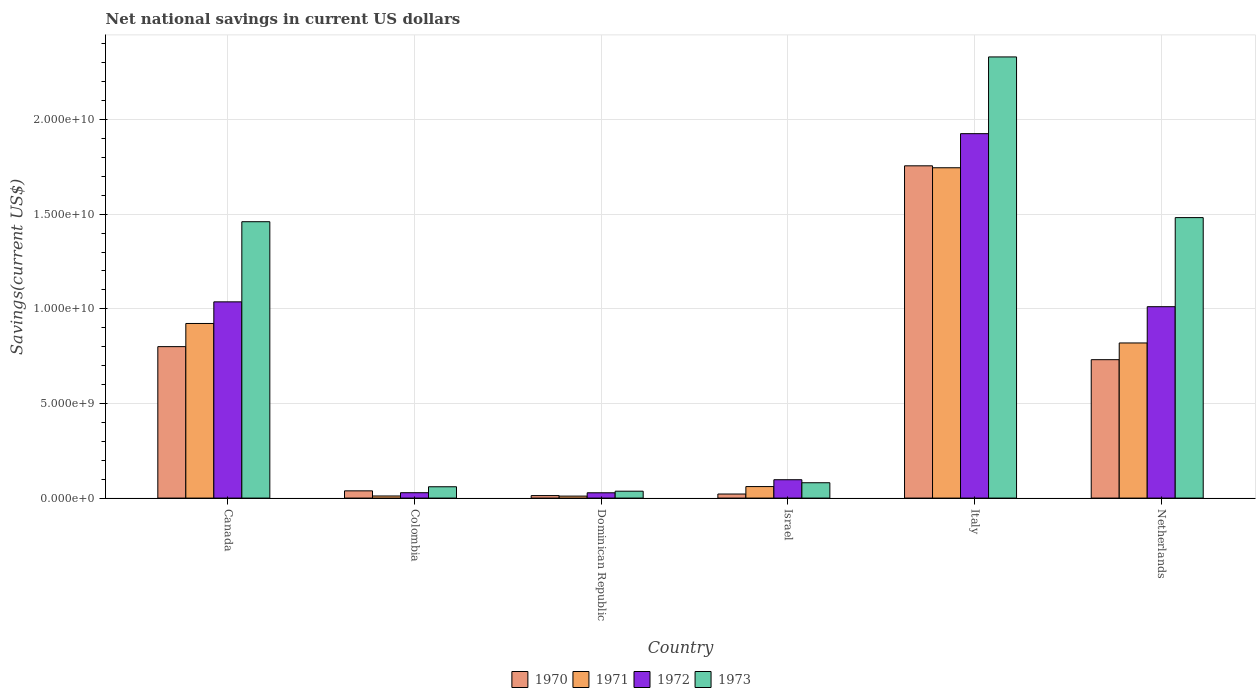How many groups of bars are there?
Give a very brief answer. 6. Are the number of bars on each tick of the X-axis equal?
Offer a very short reply. Yes. How many bars are there on the 2nd tick from the left?
Keep it short and to the point. 4. What is the label of the 1st group of bars from the left?
Make the answer very short. Canada. What is the net national savings in 1971 in Dominican Republic?
Your answer should be very brief. 1.05e+08. Across all countries, what is the maximum net national savings in 1971?
Offer a terse response. 1.75e+1. Across all countries, what is the minimum net national savings in 1970?
Provide a succinct answer. 1.33e+08. In which country was the net national savings in 1972 minimum?
Offer a terse response. Dominican Republic. What is the total net national savings in 1970 in the graph?
Ensure brevity in your answer.  3.36e+1. What is the difference between the net national savings in 1970 in Canada and that in Israel?
Your answer should be very brief. 7.79e+09. What is the difference between the net national savings in 1972 in Canada and the net national savings in 1973 in Colombia?
Ensure brevity in your answer.  9.77e+09. What is the average net national savings in 1970 per country?
Your answer should be compact. 5.60e+09. What is the difference between the net national savings of/in 1972 and net national savings of/in 1970 in Netherlands?
Provide a short and direct response. 2.80e+09. In how many countries, is the net national savings in 1972 greater than 4000000000 US$?
Provide a short and direct response. 3. What is the ratio of the net national savings in 1970 in Canada to that in Israel?
Ensure brevity in your answer.  37.28. Is the net national savings in 1970 in Canada less than that in Netherlands?
Offer a very short reply. No. What is the difference between the highest and the second highest net national savings in 1971?
Provide a short and direct response. 9.26e+09. What is the difference between the highest and the lowest net national savings in 1972?
Make the answer very short. 1.90e+1. In how many countries, is the net national savings in 1973 greater than the average net national savings in 1973 taken over all countries?
Your answer should be very brief. 3. Is the sum of the net national savings in 1973 in Dominican Republic and Netherlands greater than the maximum net national savings in 1972 across all countries?
Your answer should be very brief. No. Is it the case that in every country, the sum of the net national savings in 1970 and net national savings in 1973 is greater than the sum of net national savings in 1972 and net national savings in 1971?
Offer a terse response. No. What does the 1st bar from the left in Netherlands represents?
Offer a very short reply. 1970. What does the 4th bar from the right in Italy represents?
Your response must be concise. 1970. Is it the case that in every country, the sum of the net national savings in 1973 and net national savings in 1971 is greater than the net national savings in 1972?
Offer a very short reply. Yes. Are all the bars in the graph horizontal?
Your answer should be very brief. No. How many countries are there in the graph?
Provide a short and direct response. 6. What is the difference between two consecutive major ticks on the Y-axis?
Provide a short and direct response. 5.00e+09. Does the graph contain grids?
Keep it short and to the point. Yes. Where does the legend appear in the graph?
Offer a terse response. Bottom center. How many legend labels are there?
Offer a very short reply. 4. How are the legend labels stacked?
Provide a succinct answer. Horizontal. What is the title of the graph?
Your response must be concise. Net national savings in current US dollars. Does "2006" appear as one of the legend labels in the graph?
Offer a terse response. No. What is the label or title of the Y-axis?
Your response must be concise. Savings(current US$). What is the Savings(current US$) of 1970 in Canada?
Give a very brief answer. 8.00e+09. What is the Savings(current US$) in 1971 in Canada?
Keep it short and to the point. 9.23e+09. What is the Savings(current US$) in 1972 in Canada?
Keep it short and to the point. 1.04e+1. What is the Savings(current US$) in 1973 in Canada?
Keep it short and to the point. 1.46e+1. What is the Savings(current US$) in 1970 in Colombia?
Ensure brevity in your answer.  3.83e+08. What is the Savings(current US$) of 1971 in Colombia?
Your response must be concise. 1.11e+08. What is the Savings(current US$) in 1972 in Colombia?
Your answer should be compact. 2.84e+08. What is the Savings(current US$) in 1973 in Colombia?
Make the answer very short. 5.98e+08. What is the Savings(current US$) in 1970 in Dominican Republic?
Your response must be concise. 1.33e+08. What is the Savings(current US$) in 1971 in Dominican Republic?
Provide a succinct answer. 1.05e+08. What is the Savings(current US$) of 1972 in Dominican Republic?
Your answer should be very brief. 2.80e+08. What is the Savings(current US$) of 1973 in Dominican Republic?
Offer a terse response. 3.65e+08. What is the Savings(current US$) of 1970 in Israel?
Offer a very short reply. 2.15e+08. What is the Savings(current US$) of 1971 in Israel?
Ensure brevity in your answer.  6.09e+08. What is the Savings(current US$) in 1972 in Israel?
Offer a very short reply. 9.71e+08. What is the Savings(current US$) in 1973 in Israel?
Your answer should be compact. 8.11e+08. What is the Savings(current US$) in 1970 in Italy?
Make the answer very short. 1.76e+1. What is the Savings(current US$) of 1971 in Italy?
Give a very brief answer. 1.75e+1. What is the Savings(current US$) of 1972 in Italy?
Your answer should be very brief. 1.93e+1. What is the Savings(current US$) in 1973 in Italy?
Keep it short and to the point. 2.33e+1. What is the Savings(current US$) in 1970 in Netherlands?
Your answer should be compact. 7.31e+09. What is the Savings(current US$) of 1971 in Netherlands?
Keep it short and to the point. 8.20e+09. What is the Savings(current US$) in 1972 in Netherlands?
Offer a very short reply. 1.01e+1. What is the Savings(current US$) of 1973 in Netherlands?
Make the answer very short. 1.48e+1. Across all countries, what is the maximum Savings(current US$) of 1970?
Offer a very short reply. 1.76e+1. Across all countries, what is the maximum Savings(current US$) in 1971?
Your answer should be compact. 1.75e+1. Across all countries, what is the maximum Savings(current US$) in 1972?
Ensure brevity in your answer.  1.93e+1. Across all countries, what is the maximum Savings(current US$) in 1973?
Your response must be concise. 2.33e+1. Across all countries, what is the minimum Savings(current US$) of 1970?
Keep it short and to the point. 1.33e+08. Across all countries, what is the minimum Savings(current US$) of 1971?
Offer a terse response. 1.05e+08. Across all countries, what is the minimum Savings(current US$) in 1972?
Give a very brief answer. 2.80e+08. Across all countries, what is the minimum Savings(current US$) of 1973?
Give a very brief answer. 3.65e+08. What is the total Savings(current US$) of 1970 in the graph?
Make the answer very short. 3.36e+1. What is the total Savings(current US$) of 1971 in the graph?
Provide a short and direct response. 3.57e+1. What is the total Savings(current US$) in 1972 in the graph?
Provide a succinct answer. 4.13e+1. What is the total Savings(current US$) in 1973 in the graph?
Your answer should be compact. 5.45e+1. What is the difference between the Savings(current US$) of 1970 in Canada and that in Colombia?
Offer a very short reply. 7.62e+09. What is the difference between the Savings(current US$) in 1971 in Canada and that in Colombia?
Make the answer very short. 9.11e+09. What is the difference between the Savings(current US$) in 1972 in Canada and that in Colombia?
Give a very brief answer. 1.01e+1. What is the difference between the Savings(current US$) of 1973 in Canada and that in Colombia?
Offer a terse response. 1.40e+1. What is the difference between the Savings(current US$) of 1970 in Canada and that in Dominican Republic?
Offer a terse response. 7.87e+09. What is the difference between the Savings(current US$) of 1971 in Canada and that in Dominican Republic?
Provide a succinct answer. 9.12e+09. What is the difference between the Savings(current US$) of 1972 in Canada and that in Dominican Republic?
Offer a very short reply. 1.01e+1. What is the difference between the Savings(current US$) in 1973 in Canada and that in Dominican Republic?
Offer a terse response. 1.42e+1. What is the difference between the Savings(current US$) in 1970 in Canada and that in Israel?
Provide a short and direct response. 7.79e+09. What is the difference between the Savings(current US$) of 1971 in Canada and that in Israel?
Ensure brevity in your answer.  8.62e+09. What is the difference between the Savings(current US$) of 1972 in Canada and that in Israel?
Keep it short and to the point. 9.40e+09. What is the difference between the Savings(current US$) of 1973 in Canada and that in Israel?
Your answer should be compact. 1.38e+1. What is the difference between the Savings(current US$) in 1970 in Canada and that in Italy?
Offer a very short reply. -9.55e+09. What is the difference between the Savings(current US$) of 1971 in Canada and that in Italy?
Give a very brief answer. -8.23e+09. What is the difference between the Savings(current US$) of 1972 in Canada and that in Italy?
Offer a terse response. -8.89e+09. What is the difference between the Savings(current US$) of 1973 in Canada and that in Italy?
Make the answer very short. -8.71e+09. What is the difference between the Savings(current US$) of 1970 in Canada and that in Netherlands?
Offer a terse response. 6.89e+08. What is the difference between the Savings(current US$) of 1971 in Canada and that in Netherlands?
Your response must be concise. 1.03e+09. What is the difference between the Savings(current US$) in 1972 in Canada and that in Netherlands?
Offer a very short reply. 2.56e+08. What is the difference between the Savings(current US$) in 1973 in Canada and that in Netherlands?
Provide a succinct answer. -2.17e+08. What is the difference between the Savings(current US$) of 1970 in Colombia and that in Dominican Republic?
Provide a short and direct response. 2.50e+08. What is the difference between the Savings(current US$) of 1971 in Colombia and that in Dominican Republic?
Your answer should be compact. 6.03e+06. What is the difference between the Savings(current US$) in 1972 in Colombia and that in Dominican Republic?
Offer a very short reply. 3.48e+06. What is the difference between the Savings(current US$) in 1973 in Colombia and that in Dominican Republic?
Keep it short and to the point. 2.34e+08. What is the difference between the Savings(current US$) of 1970 in Colombia and that in Israel?
Give a very brief answer. 1.68e+08. What is the difference between the Savings(current US$) in 1971 in Colombia and that in Israel?
Offer a very short reply. -4.97e+08. What is the difference between the Savings(current US$) in 1972 in Colombia and that in Israel?
Offer a terse response. -6.87e+08. What is the difference between the Savings(current US$) of 1973 in Colombia and that in Israel?
Provide a short and direct response. -2.12e+08. What is the difference between the Savings(current US$) in 1970 in Colombia and that in Italy?
Your response must be concise. -1.72e+1. What is the difference between the Savings(current US$) of 1971 in Colombia and that in Italy?
Keep it short and to the point. -1.73e+1. What is the difference between the Savings(current US$) of 1972 in Colombia and that in Italy?
Provide a short and direct response. -1.90e+1. What is the difference between the Savings(current US$) in 1973 in Colombia and that in Italy?
Provide a short and direct response. -2.27e+1. What is the difference between the Savings(current US$) in 1970 in Colombia and that in Netherlands?
Your answer should be very brief. -6.93e+09. What is the difference between the Savings(current US$) in 1971 in Colombia and that in Netherlands?
Offer a terse response. -8.08e+09. What is the difference between the Savings(current US$) of 1972 in Colombia and that in Netherlands?
Ensure brevity in your answer.  -9.83e+09. What is the difference between the Savings(current US$) of 1973 in Colombia and that in Netherlands?
Offer a very short reply. -1.42e+1. What is the difference between the Savings(current US$) in 1970 in Dominican Republic and that in Israel?
Make the answer very short. -8.19e+07. What is the difference between the Savings(current US$) in 1971 in Dominican Republic and that in Israel?
Your answer should be compact. -5.03e+08. What is the difference between the Savings(current US$) of 1972 in Dominican Republic and that in Israel?
Give a very brief answer. -6.90e+08. What is the difference between the Savings(current US$) in 1973 in Dominican Republic and that in Israel?
Offer a very short reply. -4.46e+08. What is the difference between the Savings(current US$) of 1970 in Dominican Republic and that in Italy?
Give a very brief answer. -1.74e+1. What is the difference between the Savings(current US$) of 1971 in Dominican Republic and that in Italy?
Offer a very short reply. -1.73e+1. What is the difference between the Savings(current US$) in 1972 in Dominican Republic and that in Italy?
Provide a succinct answer. -1.90e+1. What is the difference between the Savings(current US$) of 1973 in Dominican Republic and that in Italy?
Your answer should be compact. -2.29e+1. What is the difference between the Savings(current US$) in 1970 in Dominican Republic and that in Netherlands?
Keep it short and to the point. -7.18e+09. What is the difference between the Savings(current US$) of 1971 in Dominican Republic and that in Netherlands?
Give a very brief answer. -8.09e+09. What is the difference between the Savings(current US$) of 1972 in Dominican Republic and that in Netherlands?
Provide a succinct answer. -9.83e+09. What is the difference between the Savings(current US$) in 1973 in Dominican Republic and that in Netherlands?
Your response must be concise. -1.45e+1. What is the difference between the Savings(current US$) of 1970 in Israel and that in Italy?
Offer a terse response. -1.73e+1. What is the difference between the Savings(current US$) of 1971 in Israel and that in Italy?
Your answer should be very brief. -1.68e+1. What is the difference between the Savings(current US$) of 1972 in Israel and that in Italy?
Your answer should be compact. -1.83e+1. What is the difference between the Savings(current US$) of 1973 in Israel and that in Italy?
Make the answer very short. -2.25e+1. What is the difference between the Savings(current US$) in 1970 in Israel and that in Netherlands?
Keep it short and to the point. -7.10e+09. What is the difference between the Savings(current US$) of 1971 in Israel and that in Netherlands?
Ensure brevity in your answer.  -7.59e+09. What is the difference between the Savings(current US$) of 1972 in Israel and that in Netherlands?
Give a very brief answer. -9.14e+09. What is the difference between the Savings(current US$) in 1973 in Israel and that in Netherlands?
Your response must be concise. -1.40e+1. What is the difference between the Savings(current US$) in 1970 in Italy and that in Netherlands?
Your response must be concise. 1.02e+1. What is the difference between the Savings(current US$) in 1971 in Italy and that in Netherlands?
Provide a short and direct response. 9.26e+09. What is the difference between the Savings(current US$) of 1972 in Italy and that in Netherlands?
Make the answer very short. 9.14e+09. What is the difference between the Savings(current US$) of 1973 in Italy and that in Netherlands?
Provide a short and direct response. 8.49e+09. What is the difference between the Savings(current US$) in 1970 in Canada and the Savings(current US$) in 1971 in Colombia?
Provide a short and direct response. 7.89e+09. What is the difference between the Savings(current US$) of 1970 in Canada and the Savings(current US$) of 1972 in Colombia?
Make the answer very short. 7.72e+09. What is the difference between the Savings(current US$) in 1970 in Canada and the Savings(current US$) in 1973 in Colombia?
Your response must be concise. 7.40e+09. What is the difference between the Savings(current US$) of 1971 in Canada and the Savings(current US$) of 1972 in Colombia?
Keep it short and to the point. 8.94e+09. What is the difference between the Savings(current US$) of 1971 in Canada and the Savings(current US$) of 1973 in Colombia?
Give a very brief answer. 8.63e+09. What is the difference between the Savings(current US$) of 1972 in Canada and the Savings(current US$) of 1973 in Colombia?
Offer a very short reply. 9.77e+09. What is the difference between the Savings(current US$) in 1970 in Canada and the Savings(current US$) in 1971 in Dominican Republic?
Give a very brief answer. 7.90e+09. What is the difference between the Savings(current US$) in 1970 in Canada and the Savings(current US$) in 1972 in Dominican Republic?
Provide a short and direct response. 7.72e+09. What is the difference between the Savings(current US$) of 1970 in Canada and the Savings(current US$) of 1973 in Dominican Republic?
Your answer should be compact. 7.64e+09. What is the difference between the Savings(current US$) in 1971 in Canada and the Savings(current US$) in 1972 in Dominican Republic?
Give a very brief answer. 8.94e+09. What is the difference between the Savings(current US$) of 1971 in Canada and the Savings(current US$) of 1973 in Dominican Republic?
Give a very brief answer. 8.86e+09. What is the difference between the Savings(current US$) in 1972 in Canada and the Savings(current US$) in 1973 in Dominican Republic?
Provide a succinct answer. 1.00e+1. What is the difference between the Savings(current US$) in 1970 in Canada and the Savings(current US$) in 1971 in Israel?
Your answer should be compact. 7.39e+09. What is the difference between the Savings(current US$) in 1970 in Canada and the Savings(current US$) in 1972 in Israel?
Your answer should be very brief. 7.03e+09. What is the difference between the Savings(current US$) in 1970 in Canada and the Savings(current US$) in 1973 in Israel?
Keep it short and to the point. 7.19e+09. What is the difference between the Savings(current US$) in 1971 in Canada and the Savings(current US$) in 1972 in Israel?
Offer a terse response. 8.25e+09. What is the difference between the Savings(current US$) in 1971 in Canada and the Savings(current US$) in 1973 in Israel?
Give a very brief answer. 8.41e+09. What is the difference between the Savings(current US$) in 1972 in Canada and the Savings(current US$) in 1973 in Israel?
Ensure brevity in your answer.  9.56e+09. What is the difference between the Savings(current US$) in 1970 in Canada and the Savings(current US$) in 1971 in Italy?
Make the answer very short. -9.45e+09. What is the difference between the Savings(current US$) in 1970 in Canada and the Savings(current US$) in 1972 in Italy?
Your response must be concise. -1.13e+1. What is the difference between the Savings(current US$) in 1970 in Canada and the Savings(current US$) in 1973 in Italy?
Offer a terse response. -1.53e+1. What is the difference between the Savings(current US$) of 1971 in Canada and the Savings(current US$) of 1972 in Italy?
Keep it short and to the point. -1.00e+1. What is the difference between the Savings(current US$) in 1971 in Canada and the Savings(current US$) in 1973 in Italy?
Offer a very short reply. -1.41e+1. What is the difference between the Savings(current US$) in 1972 in Canada and the Savings(current US$) in 1973 in Italy?
Your answer should be very brief. -1.29e+1. What is the difference between the Savings(current US$) of 1970 in Canada and the Savings(current US$) of 1971 in Netherlands?
Ensure brevity in your answer.  -1.94e+08. What is the difference between the Savings(current US$) of 1970 in Canada and the Savings(current US$) of 1972 in Netherlands?
Offer a terse response. -2.11e+09. What is the difference between the Savings(current US$) of 1970 in Canada and the Savings(current US$) of 1973 in Netherlands?
Ensure brevity in your answer.  -6.82e+09. What is the difference between the Savings(current US$) of 1971 in Canada and the Savings(current US$) of 1972 in Netherlands?
Provide a succinct answer. -8.87e+08. What is the difference between the Savings(current US$) of 1971 in Canada and the Savings(current US$) of 1973 in Netherlands?
Offer a very short reply. -5.59e+09. What is the difference between the Savings(current US$) in 1972 in Canada and the Savings(current US$) in 1973 in Netherlands?
Your response must be concise. -4.45e+09. What is the difference between the Savings(current US$) in 1970 in Colombia and the Savings(current US$) in 1971 in Dominican Republic?
Ensure brevity in your answer.  2.77e+08. What is the difference between the Savings(current US$) of 1970 in Colombia and the Savings(current US$) of 1972 in Dominican Republic?
Give a very brief answer. 1.02e+08. What is the difference between the Savings(current US$) of 1970 in Colombia and the Savings(current US$) of 1973 in Dominican Republic?
Your response must be concise. 1.82e+07. What is the difference between the Savings(current US$) of 1971 in Colombia and the Savings(current US$) of 1972 in Dominican Republic?
Give a very brief answer. -1.69e+08. What is the difference between the Savings(current US$) of 1971 in Colombia and the Savings(current US$) of 1973 in Dominican Republic?
Offer a very short reply. -2.53e+08. What is the difference between the Savings(current US$) in 1972 in Colombia and the Savings(current US$) in 1973 in Dominican Republic?
Provide a short and direct response. -8.05e+07. What is the difference between the Savings(current US$) in 1970 in Colombia and the Savings(current US$) in 1971 in Israel?
Your answer should be very brief. -2.26e+08. What is the difference between the Savings(current US$) in 1970 in Colombia and the Savings(current US$) in 1972 in Israel?
Provide a short and direct response. -5.88e+08. What is the difference between the Savings(current US$) of 1970 in Colombia and the Savings(current US$) of 1973 in Israel?
Offer a very short reply. -4.28e+08. What is the difference between the Savings(current US$) of 1971 in Colombia and the Savings(current US$) of 1972 in Israel?
Ensure brevity in your answer.  -8.59e+08. What is the difference between the Savings(current US$) of 1971 in Colombia and the Savings(current US$) of 1973 in Israel?
Give a very brief answer. -6.99e+08. What is the difference between the Savings(current US$) of 1972 in Colombia and the Savings(current US$) of 1973 in Israel?
Make the answer very short. -5.27e+08. What is the difference between the Savings(current US$) in 1970 in Colombia and the Savings(current US$) in 1971 in Italy?
Offer a very short reply. -1.71e+1. What is the difference between the Savings(current US$) in 1970 in Colombia and the Savings(current US$) in 1972 in Italy?
Make the answer very short. -1.89e+1. What is the difference between the Savings(current US$) of 1970 in Colombia and the Savings(current US$) of 1973 in Italy?
Your response must be concise. -2.29e+1. What is the difference between the Savings(current US$) in 1971 in Colombia and the Savings(current US$) in 1972 in Italy?
Provide a short and direct response. -1.91e+1. What is the difference between the Savings(current US$) of 1971 in Colombia and the Savings(current US$) of 1973 in Italy?
Keep it short and to the point. -2.32e+1. What is the difference between the Savings(current US$) of 1972 in Colombia and the Savings(current US$) of 1973 in Italy?
Your answer should be very brief. -2.30e+1. What is the difference between the Savings(current US$) of 1970 in Colombia and the Savings(current US$) of 1971 in Netherlands?
Your response must be concise. -7.81e+09. What is the difference between the Savings(current US$) in 1970 in Colombia and the Savings(current US$) in 1972 in Netherlands?
Make the answer very short. -9.73e+09. What is the difference between the Savings(current US$) in 1970 in Colombia and the Savings(current US$) in 1973 in Netherlands?
Offer a very short reply. -1.44e+1. What is the difference between the Savings(current US$) of 1971 in Colombia and the Savings(current US$) of 1972 in Netherlands?
Offer a terse response. -1.00e+1. What is the difference between the Savings(current US$) in 1971 in Colombia and the Savings(current US$) in 1973 in Netherlands?
Provide a short and direct response. -1.47e+1. What is the difference between the Savings(current US$) in 1972 in Colombia and the Savings(current US$) in 1973 in Netherlands?
Offer a very short reply. -1.45e+1. What is the difference between the Savings(current US$) of 1970 in Dominican Republic and the Savings(current US$) of 1971 in Israel?
Make the answer very short. -4.76e+08. What is the difference between the Savings(current US$) in 1970 in Dominican Republic and the Savings(current US$) in 1972 in Israel?
Offer a terse response. -8.38e+08. What is the difference between the Savings(current US$) in 1970 in Dominican Republic and the Savings(current US$) in 1973 in Israel?
Give a very brief answer. -6.78e+08. What is the difference between the Savings(current US$) in 1971 in Dominican Republic and the Savings(current US$) in 1972 in Israel?
Offer a terse response. -8.65e+08. What is the difference between the Savings(current US$) in 1971 in Dominican Republic and the Savings(current US$) in 1973 in Israel?
Ensure brevity in your answer.  -7.05e+08. What is the difference between the Savings(current US$) of 1972 in Dominican Republic and the Savings(current US$) of 1973 in Israel?
Your answer should be very brief. -5.30e+08. What is the difference between the Savings(current US$) of 1970 in Dominican Republic and the Savings(current US$) of 1971 in Italy?
Offer a very short reply. -1.73e+1. What is the difference between the Savings(current US$) of 1970 in Dominican Republic and the Savings(current US$) of 1972 in Italy?
Your answer should be very brief. -1.91e+1. What is the difference between the Savings(current US$) in 1970 in Dominican Republic and the Savings(current US$) in 1973 in Italy?
Provide a succinct answer. -2.32e+1. What is the difference between the Savings(current US$) in 1971 in Dominican Republic and the Savings(current US$) in 1972 in Italy?
Keep it short and to the point. -1.91e+1. What is the difference between the Savings(current US$) in 1971 in Dominican Republic and the Savings(current US$) in 1973 in Italy?
Offer a very short reply. -2.32e+1. What is the difference between the Savings(current US$) of 1972 in Dominican Republic and the Savings(current US$) of 1973 in Italy?
Give a very brief answer. -2.30e+1. What is the difference between the Savings(current US$) in 1970 in Dominican Republic and the Savings(current US$) in 1971 in Netherlands?
Give a very brief answer. -8.06e+09. What is the difference between the Savings(current US$) of 1970 in Dominican Republic and the Savings(current US$) of 1972 in Netherlands?
Offer a very short reply. -9.98e+09. What is the difference between the Savings(current US$) in 1970 in Dominican Republic and the Savings(current US$) in 1973 in Netherlands?
Ensure brevity in your answer.  -1.47e+1. What is the difference between the Savings(current US$) in 1971 in Dominican Republic and the Savings(current US$) in 1972 in Netherlands?
Offer a very short reply. -1.00e+1. What is the difference between the Savings(current US$) of 1971 in Dominican Republic and the Savings(current US$) of 1973 in Netherlands?
Offer a very short reply. -1.47e+1. What is the difference between the Savings(current US$) of 1972 in Dominican Republic and the Savings(current US$) of 1973 in Netherlands?
Your answer should be compact. -1.45e+1. What is the difference between the Savings(current US$) of 1970 in Israel and the Savings(current US$) of 1971 in Italy?
Your answer should be compact. -1.72e+1. What is the difference between the Savings(current US$) of 1970 in Israel and the Savings(current US$) of 1972 in Italy?
Provide a succinct answer. -1.90e+1. What is the difference between the Savings(current US$) of 1970 in Israel and the Savings(current US$) of 1973 in Italy?
Make the answer very short. -2.31e+1. What is the difference between the Savings(current US$) in 1971 in Israel and the Savings(current US$) in 1972 in Italy?
Keep it short and to the point. -1.86e+1. What is the difference between the Savings(current US$) in 1971 in Israel and the Savings(current US$) in 1973 in Italy?
Your answer should be compact. -2.27e+1. What is the difference between the Savings(current US$) in 1972 in Israel and the Savings(current US$) in 1973 in Italy?
Offer a terse response. -2.23e+1. What is the difference between the Savings(current US$) of 1970 in Israel and the Savings(current US$) of 1971 in Netherlands?
Keep it short and to the point. -7.98e+09. What is the difference between the Savings(current US$) of 1970 in Israel and the Savings(current US$) of 1972 in Netherlands?
Provide a succinct answer. -9.90e+09. What is the difference between the Savings(current US$) of 1970 in Israel and the Savings(current US$) of 1973 in Netherlands?
Keep it short and to the point. -1.46e+1. What is the difference between the Savings(current US$) of 1971 in Israel and the Savings(current US$) of 1972 in Netherlands?
Offer a very short reply. -9.50e+09. What is the difference between the Savings(current US$) in 1971 in Israel and the Savings(current US$) in 1973 in Netherlands?
Offer a very short reply. -1.42e+1. What is the difference between the Savings(current US$) in 1972 in Israel and the Savings(current US$) in 1973 in Netherlands?
Ensure brevity in your answer.  -1.38e+1. What is the difference between the Savings(current US$) of 1970 in Italy and the Savings(current US$) of 1971 in Netherlands?
Your response must be concise. 9.36e+09. What is the difference between the Savings(current US$) of 1970 in Italy and the Savings(current US$) of 1972 in Netherlands?
Make the answer very short. 7.44e+09. What is the difference between the Savings(current US$) in 1970 in Italy and the Savings(current US$) in 1973 in Netherlands?
Make the answer very short. 2.74e+09. What is the difference between the Savings(current US$) in 1971 in Italy and the Savings(current US$) in 1972 in Netherlands?
Provide a succinct answer. 7.34e+09. What is the difference between the Savings(current US$) in 1971 in Italy and the Savings(current US$) in 1973 in Netherlands?
Offer a very short reply. 2.63e+09. What is the difference between the Savings(current US$) of 1972 in Italy and the Savings(current US$) of 1973 in Netherlands?
Give a very brief answer. 4.44e+09. What is the average Savings(current US$) of 1970 per country?
Give a very brief answer. 5.60e+09. What is the average Savings(current US$) in 1971 per country?
Provide a short and direct response. 5.95e+09. What is the average Savings(current US$) of 1972 per country?
Provide a short and direct response. 6.88e+09. What is the average Savings(current US$) of 1973 per country?
Your answer should be compact. 9.08e+09. What is the difference between the Savings(current US$) of 1970 and Savings(current US$) of 1971 in Canada?
Provide a short and direct response. -1.22e+09. What is the difference between the Savings(current US$) in 1970 and Savings(current US$) in 1972 in Canada?
Offer a very short reply. -2.37e+09. What is the difference between the Savings(current US$) in 1970 and Savings(current US$) in 1973 in Canada?
Your answer should be compact. -6.60e+09. What is the difference between the Savings(current US$) in 1971 and Savings(current US$) in 1972 in Canada?
Give a very brief answer. -1.14e+09. What is the difference between the Savings(current US$) of 1971 and Savings(current US$) of 1973 in Canada?
Make the answer very short. -5.38e+09. What is the difference between the Savings(current US$) of 1972 and Savings(current US$) of 1973 in Canada?
Provide a short and direct response. -4.23e+09. What is the difference between the Savings(current US$) of 1970 and Savings(current US$) of 1971 in Colombia?
Make the answer very short. 2.71e+08. What is the difference between the Savings(current US$) in 1970 and Savings(current US$) in 1972 in Colombia?
Ensure brevity in your answer.  9.87e+07. What is the difference between the Savings(current US$) in 1970 and Savings(current US$) in 1973 in Colombia?
Your answer should be compact. -2.16e+08. What is the difference between the Savings(current US$) in 1971 and Savings(current US$) in 1972 in Colombia?
Your answer should be very brief. -1.73e+08. What is the difference between the Savings(current US$) of 1971 and Savings(current US$) of 1973 in Colombia?
Provide a succinct answer. -4.87e+08. What is the difference between the Savings(current US$) of 1972 and Savings(current US$) of 1973 in Colombia?
Make the answer very short. -3.14e+08. What is the difference between the Savings(current US$) of 1970 and Savings(current US$) of 1971 in Dominican Republic?
Provide a short and direct response. 2.74e+07. What is the difference between the Savings(current US$) of 1970 and Savings(current US$) of 1972 in Dominican Republic?
Provide a short and direct response. -1.48e+08. What is the difference between the Savings(current US$) of 1970 and Savings(current US$) of 1973 in Dominican Republic?
Ensure brevity in your answer.  -2.32e+08. What is the difference between the Savings(current US$) in 1971 and Savings(current US$) in 1972 in Dominican Republic?
Offer a terse response. -1.75e+08. What is the difference between the Savings(current US$) of 1971 and Savings(current US$) of 1973 in Dominican Republic?
Your response must be concise. -2.59e+08. What is the difference between the Savings(current US$) in 1972 and Savings(current US$) in 1973 in Dominican Republic?
Provide a succinct answer. -8.40e+07. What is the difference between the Savings(current US$) of 1970 and Savings(current US$) of 1971 in Israel?
Offer a terse response. -3.94e+08. What is the difference between the Savings(current US$) of 1970 and Savings(current US$) of 1972 in Israel?
Offer a very short reply. -7.56e+08. What is the difference between the Savings(current US$) in 1970 and Savings(current US$) in 1973 in Israel?
Offer a terse response. -5.96e+08. What is the difference between the Savings(current US$) of 1971 and Savings(current US$) of 1972 in Israel?
Ensure brevity in your answer.  -3.62e+08. What is the difference between the Savings(current US$) of 1971 and Savings(current US$) of 1973 in Israel?
Provide a short and direct response. -2.02e+08. What is the difference between the Savings(current US$) of 1972 and Savings(current US$) of 1973 in Israel?
Keep it short and to the point. 1.60e+08. What is the difference between the Savings(current US$) of 1970 and Savings(current US$) of 1971 in Italy?
Your answer should be very brief. 1.03e+08. What is the difference between the Savings(current US$) in 1970 and Savings(current US$) in 1972 in Italy?
Make the answer very short. -1.70e+09. What is the difference between the Savings(current US$) in 1970 and Savings(current US$) in 1973 in Italy?
Make the answer very short. -5.75e+09. What is the difference between the Savings(current US$) in 1971 and Savings(current US$) in 1972 in Italy?
Offer a very short reply. -1.80e+09. What is the difference between the Savings(current US$) of 1971 and Savings(current US$) of 1973 in Italy?
Give a very brief answer. -5.86e+09. What is the difference between the Savings(current US$) of 1972 and Savings(current US$) of 1973 in Italy?
Offer a terse response. -4.05e+09. What is the difference between the Savings(current US$) in 1970 and Savings(current US$) in 1971 in Netherlands?
Ensure brevity in your answer.  -8.83e+08. What is the difference between the Savings(current US$) in 1970 and Savings(current US$) in 1972 in Netherlands?
Make the answer very short. -2.80e+09. What is the difference between the Savings(current US$) of 1970 and Savings(current US$) of 1973 in Netherlands?
Offer a very short reply. -7.51e+09. What is the difference between the Savings(current US$) in 1971 and Savings(current US$) in 1972 in Netherlands?
Give a very brief answer. -1.92e+09. What is the difference between the Savings(current US$) of 1971 and Savings(current US$) of 1973 in Netherlands?
Your answer should be compact. -6.62e+09. What is the difference between the Savings(current US$) in 1972 and Savings(current US$) in 1973 in Netherlands?
Offer a terse response. -4.71e+09. What is the ratio of the Savings(current US$) in 1970 in Canada to that in Colombia?
Offer a terse response. 20.91. What is the ratio of the Savings(current US$) in 1971 in Canada to that in Colombia?
Your answer should be very brief. 82.79. What is the ratio of the Savings(current US$) of 1972 in Canada to that in Colombia?
Offer a terse response. 36.51. What is the ratio of the Savings(current US$) in 1973 in Canada to that in Colombia?
Offer a terse response. 24.4. What is the ratio of the Savings(current US$) of 1970 in Canada to that in Dominican Republic?
Your answer should be compact. 60.27. What is the ratio of the Savings(current US$) in 1971 in Canada to that in Dominican Republic?
Keep it short and to the point. 87.52. What is the ratio of the Savings(current US$) in 1972 in Canada to that in Dominican Republic?
Offer a terse response. 36.96. What is the ratio of the Savings(current US$) in 1973 in Canada to that in Dominican Republic?
Make the answer very short. 40.06. What is the ratio of the Savings(current US$) of 1970 in Canada to that in Israel?
Provide a succinct answer. 37.28. What is the ratio of the Savings(current US$) of 1971 in Canada to that in Israel?
Provide a succinct answer. 15.16. What is the ratio of the Savings(current US$) in 1972 in Canada to that in Israel?
Keep it short and to the point. 10.68. What is the ratio of the Savings(current US$) of 1973 in Canada to that in Israel?
Provide a succinct answer. 18.01. What is the ratio of the Savings(current US$) of 1970 in Canada to that in Italy?
Make the answer very short. 0.46. What is the ratio of the Savings(current US$) of 1971 in Canada to that in Italy?
Your answer should be compact. 0.53. What is the ratio of the Savings(current US$) in 1972 in Canada to that in Italy?
Offer a terse response. 0.54. What is the ratio of the Savings(current US$) in 1973 in Canada to that in Italy?
Your answer should be compact. 0.63. What is the ratio of the Savings(current US$) in 1970 in Canada to that in Netherlands?
Offer a terse response. 1.09. What is the ratio of the Savings(current US$) in 1971 in Canada to that in Netherlands?
Make the answer very short. 1.13. What is the ratio of the Savings(current US$) of 1972 in Canada to that in Netherlands?
Your response must be concise. 1.03. What is the ratio of the Savings(current US$) in 1973 in Canada to that in Netherlands?
Give a very brief answer. 0.99. What is the ratio of the Savings(current US$) in 1970 in Colombia to that in Dominican Republic?
Ensure brevity in your answer.  2.88. What is the ratio of the Savings(current US$) in 1971 in Colombia to that in Dominican Republic?
Keep it short and to the point. 1.06. What is the ratio of the Savings(current US$) of 1972 in Colombia to that in Dominican Republic?
Your answer should be very brief. 1.01. What is the ratio of the Savings(current US$) in 1973 in Colombia to that in Dominican Republic?
Make the answer very short. 1.64. What is the ratio of the Savings(current US$) in 1970 in Colombia to that in Israel?
Your response must be concise. 1.78. What is the ratio of the Savings(current US$) in 1971 in Colombia to that in Israel?
Provide a short and direct response. 0.18. What is the ratio of the Savings(current US$) of 1972 in Colombia to that in Israel?
Your answer should be compact. 0.29. What is the ratio of the Savings(current US$) of 1973 in Colombia to that in Israel?
Provide a short and direct response. 0.74. What is the ratio of the Savings(current US$) of 1970 in Colombia to that in Italy?
Your answer should be very brief. 0.02. What is the ratio of the Savings(current US$) of 1971 in Colombia to that in Italy?
Your response must be concise. 0.01. What is the ratio of the Savings(current US$) of 1972 in Colombia to that in Italy?
Ensure brevity in your answer.  0.01. What is the ratio of the Savings(current US$) of 1973 in Colombia to that in Italy?
Your answer should be compact. 0.03. What is the ratio of the Savings(current US$) in 1970 in Colombia to that in Netherlands?
Ensure brevity in your answer.  0.05. What is the ratio of the Savings(current US$) of 1971 in Colombia to that in Netherlands?
Offer a terse response. 0.01. What is the ratio of the Savings(current US$) in 1972 in Colombia to that in Netherlands?
Your answer should be very brief. 0.03. What is the ratio of the Savings(current US$) in 1973 in Colombia to that in Netherlands?
Give a very brief answer. 0.04. What is the ratio of the Savings(current US$) of 1970 in Dominican Republic to that in Israel?
Offer a terse response. 0.62. What is the ratio of the Savings(current US$) in 1971 in Dominican Republic to that in Israel?
Your response must be concise. 0.17. What is the ratio of the Savings(current US$) in 1972 in Dominican Republic to that in Israel?
Ensure brevity in your answer.  0.29. What is the ratio of the Savings(current US$) in 1973 in Dominican Republic to that in Israel?
Ensure brevity in your answer.  0.45. What is the ratio of the Savings(current US$) in 1970 in Dominican Republic to that in Italy?
Your answer should be compact. 0.01. What is the ratio of the Savings(current US$) of 1971 in Dominican Republic to that in Italy?
Offer a very short reply. 0.01. What is the ratio of the Savings(current US$) of 1972 in Dominican Republic to that in Italy?
Provide a succinct answer. 0.01. What is the ratio of the Savings(current US$) of 1973 in Dominican Republic to that in Italy?
Give a very brief answer. 0.02. What is the ratio of the Savings(current US$) of 1970 in Dominican Republic to that in Netherlands?
Provide a short and direct response. 0.02. What is the ratio of the Savings(current US$) of 1971 in Dominican Republic to that in Netherlands?
Keep it short and to the point. 0.01. What is the ratio of the Savings(current US$) of 1972 in Dominican Republic to that in Netherlands?
Your answer should be compact. 0.03. What is the ratio of the Savings(current US$) of 1973 in Dominican Republic to that in Netherlands?
Ensure brevity in your answer.  0.02. What is the ratio of the Savings(current US$) of 1970 in Israel to that in Italy?
Your answer should be very brief. 0.01. What is the ratio of the Savings(current US$) of 1971 in Israel to that in Italy?
Provide a short and direct response. 0.03. What is the ratio of the Savings(current US$) in 1972 in Israel to that in Italy?
Offer a very short reply. 0.05. What is the ratio of the Savings(current US$) in 1973 in Israel to that in Italy?
Your answer should be compact. 0.03. What is the ratio of the Savings(current US$) of 1970 in Israel to that in Netherlands?
Your answer should be very brief. 0.03. What is the ratio of the Savings(current US$) in 1971 in Israel to that in Netherlands?
Your answer should be compact. 0.07. What is the ratio of the Savings(current US$) in 1972 in Israel to that in Netherlands?
Your answer should be very brief. 0.1. What is the ratio of the Savings(current US$) of 1973 in Israel to that in Netherlands?
Your response must be concise. 0.05. What is the ratio of the Savings(current US$) in 1970 in Italy to that in Netherlands?
Ensure brevity in your answer.  2.4. What is the ratio of the Savings(current US$) in 1971 in Italy to that in Netherlands?
Provide a short and direct response. 2.13. What is the ratio of the Savings(current US$) in 1972 in Italy to that in Netherlands?
Provide a short and direct response. 1.9. What is the ratio of the Savings(current US$) of 1973 in Italy to that in Netherlands?
Give a very brief answer. 1.57. What is the difference between the highest and the second highest Savings(current US$) in 1970?
Make the answer very short. 9.55e+09. What is the difference between the highest and the second highest Savings(current US$) in 1971?
Your answer should be compact. 8.23e+09. What is the difference between the highest and the second highest Savings(current US$) of 1972?
Keep it short and to the point. 8.89e+09. What is the difference between the highest and the second highest Savings(current US$) of 1973?
Your response must be concise. 8.49e+09. What is the difference between the highest and the lowest Savings(current US$) in 1970?
Your answer should be compact. 1.74e+1. What is the difference between the highest and the lowest Savings(current US$) in 1971?
Your response must be concise. 1.73e+1. What is the difference between the highest and the lowest Savings(current US$) of 1972?
Make the answer very short. 1.90e+1. What is the difference between the highest and the lowest Savings(current US$) of 1973?
Offer a very short reply. 2.29e+1. 